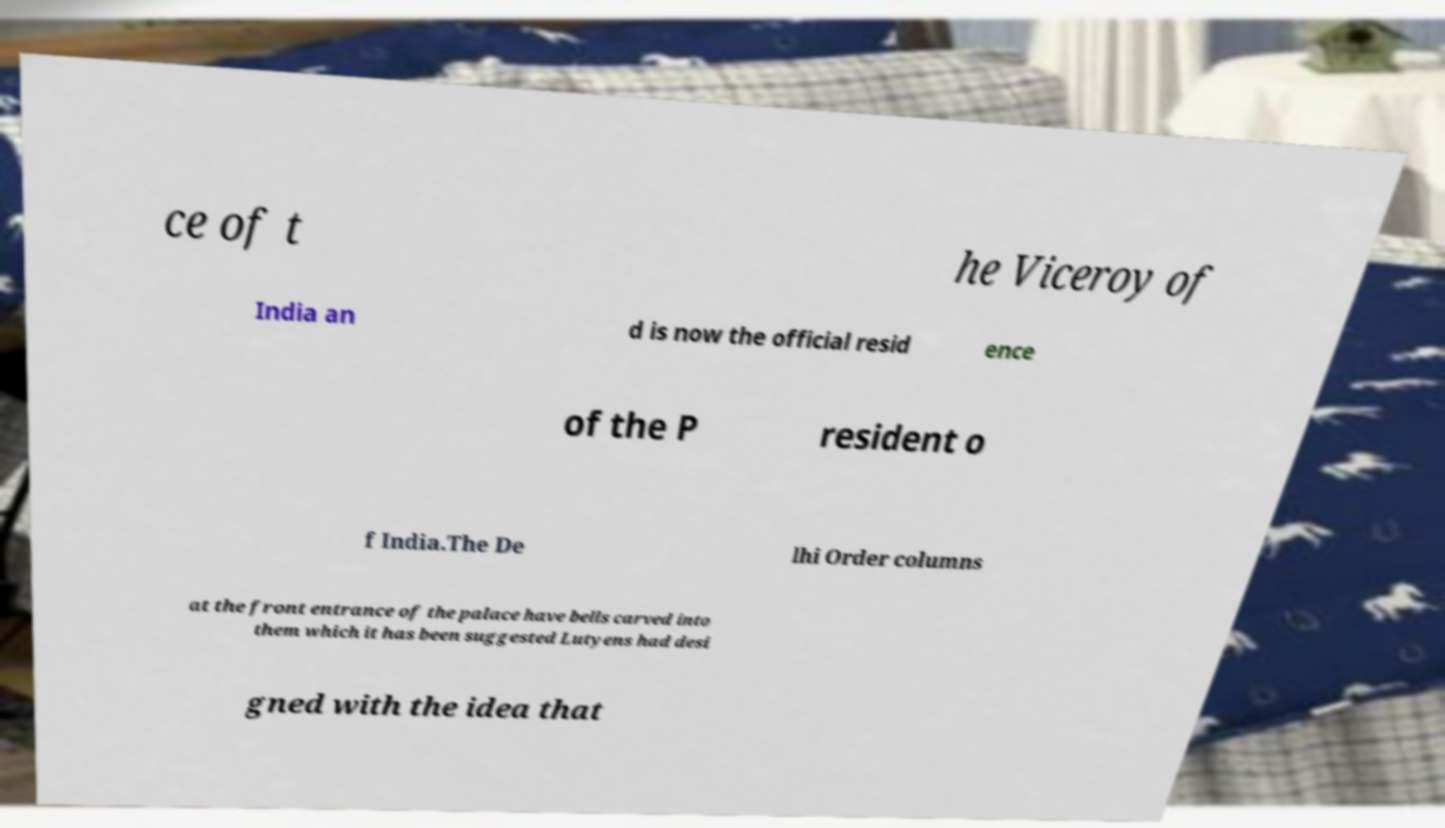Can you accurately transcribe the text from the provided image for me? ce of t he Viceroy of India an d is now the official resid ence of the P resident o f India.The De lhi Order columns at the front entrance of the palace have bells carved into them which it has been suggested Lutyens had desi gned with the idea that 